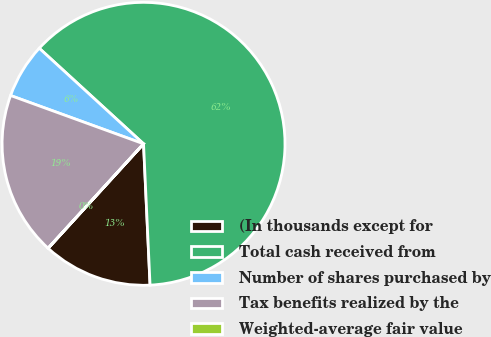Convert chart. <chart><loc_0><loc_0><loc_500><loc_500><pie_chart><fcel>(In thousands except for<fcel>Total cash received from<fcel>Number of shares purchased by<fcel>Tax benefits realized by the<fcel>Weighted-average fair value<nl><fcel>12.51%<fcel>62.46%<fcel>6.26%<fcel>18.75%<fcel>0.02%<nl></chart> 